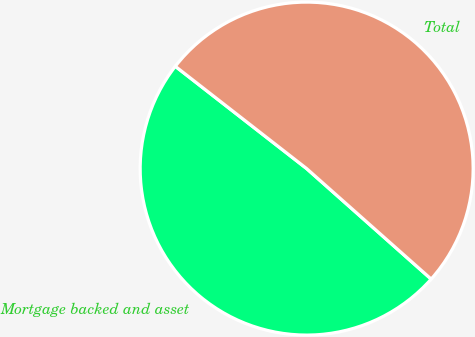Convert chart to OTSL. <chart><loc_0><loc_0><loc_500><loc_500><pie_chart><fcel>Mortgage backed and asset<fcel>Total<nl><fcel>48.98%<fcel>51.02%<nl></chart> 